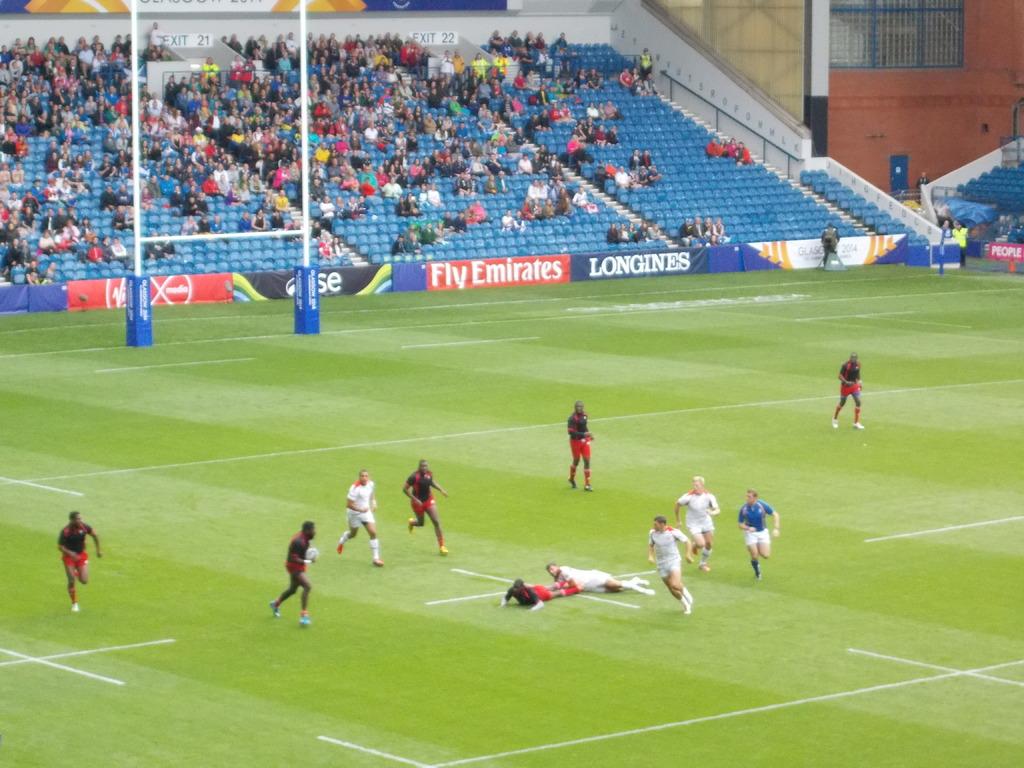The sign says fly what?
Your answer should be compact. Emirates. 